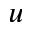<formula> <loc_0><loc_0><loc_500><loc_500>u</formula> 